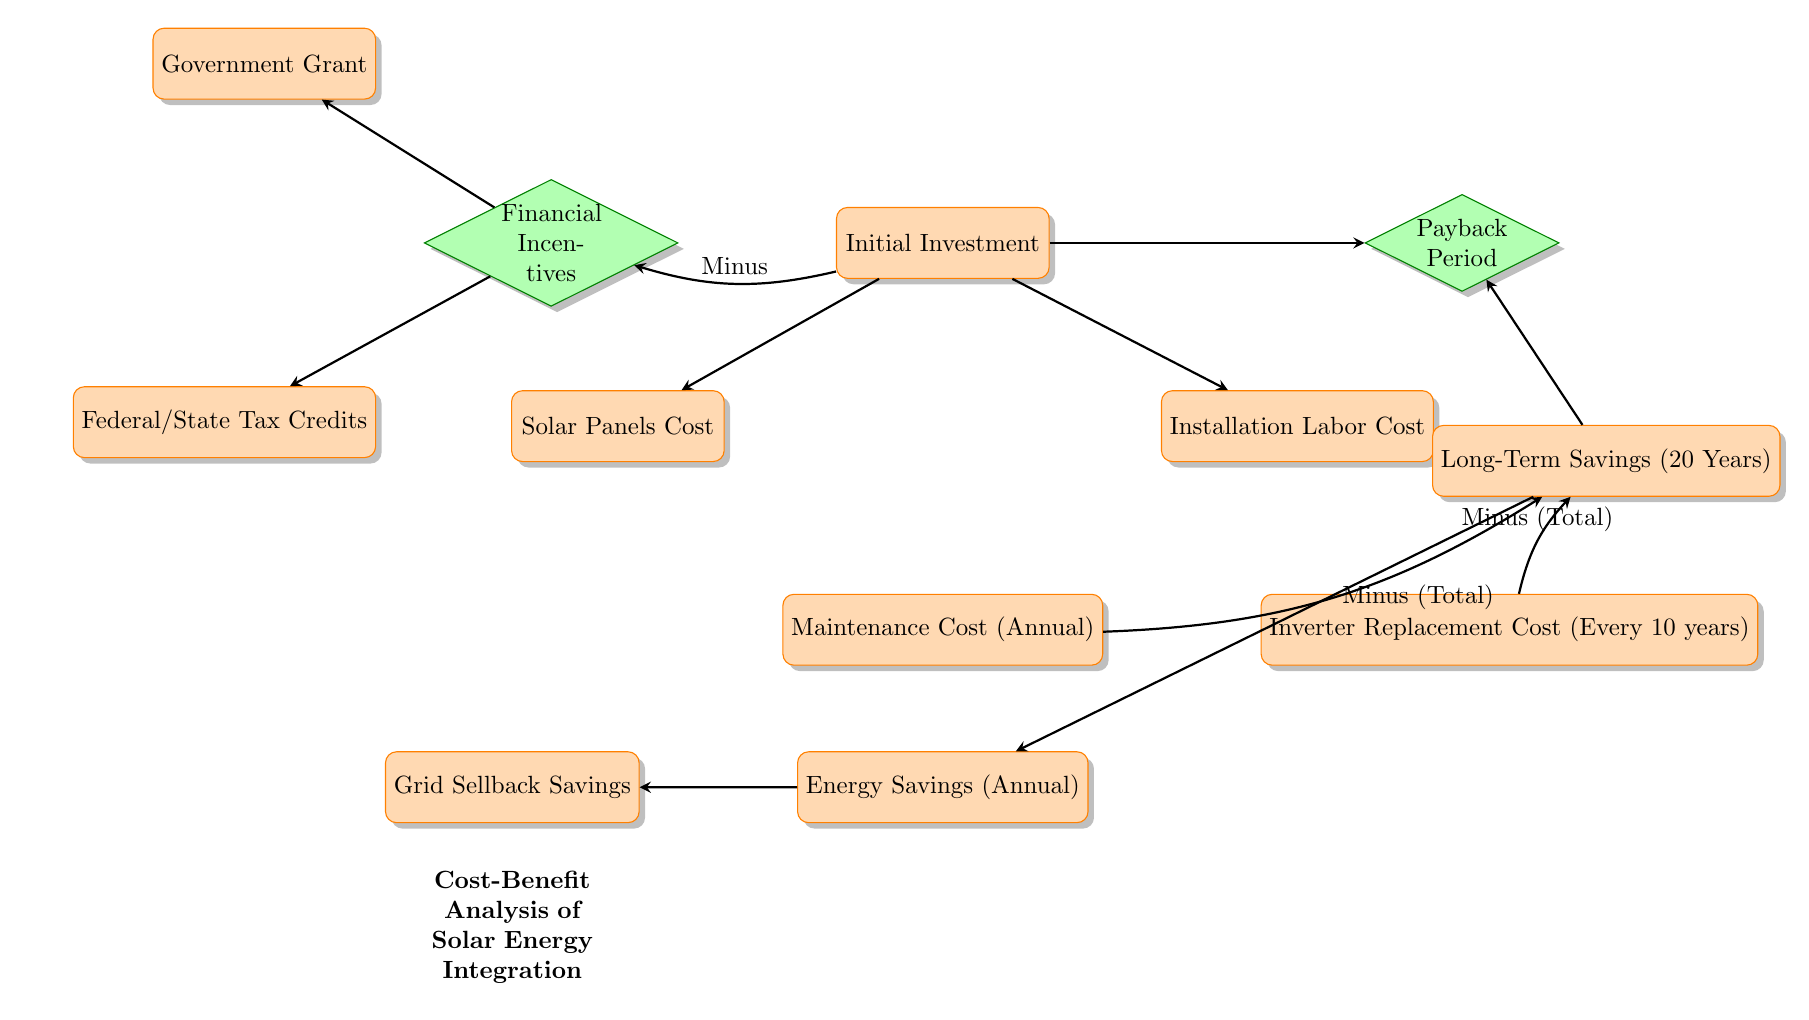What is the first node in the diagram? The first node in the diagram is labeled "Initial Investment," which indicates the starting point for the cost-benefit analysis of solar energy integration.
Answer: Initial Investment How many types of costs are illustrated in the diagram? The diagram illustrates three types of costs: Solar Panels Cost, Installation Labor Cost, and Maintenance Cost (Annual), plus Inverter Replacement Cost. Therefore, there are four types of costs represented.
Answer: 4 What does the "Financial Incentives" decision node directly influence? The "Financial Incentives" decision node directly influences the flow to the Government Grant and Federal/State Tax Credits, which lead to reduced initial investment costs.
Answer: Government Grant and Federal/State Tax Credits What represents the long-term financial benefits in the diagram? The long-term financial benefits are represented by the node "Long-Term Savings (20 Years)," which captures savings accrued over two decades.
Answer: Long-Term Savings (20 Years) How is the Payback Period calculated in the context of the diagram? The Payback Period is calculated based on the flow from the Initial Investment node, which also takes into account the Long-Term Savings node; it reflects the time taken to recover the initial investment from energy savings.
Answer: From initial investment and long-term savings What are the two savings types illustrated in the diagram? The two types of savings illustrated are "Energy Savings (Annual)" and "Grid Sellback Savings," which represent the financial benefits gained from solar energy integration.
Answer: Energy Savings (Annual) and Grid Sellback Savings Which cost recurs every 10 years in the diagram? The "Inverter Replacement Cost" is the cost that recurs every 10 years, as specified in the diagram.
Answer: Inverter Replacement Cost How do annual maintenance costs impact long-term savings? Annual maintenance costs impact long-term savings by being subtracted from the total long-term savings, as indicated by the arrow pointing from Maintenance Cost to Long-Term Savings in the diagram.
Answer: They are subtracted from total savings What is the final outcome represented by the "Payback Period" decision node? The final outcome represented by the "Payback Period" decision node is the time it will take to recoup the initial solar energy investment through accumulated savings, which is a crucial metric for financial analysis.
Answer: Time to recoup investment 